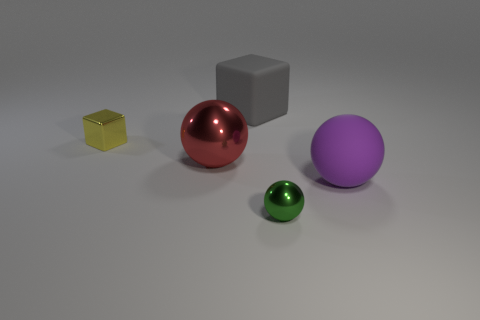Add 3 tiny gray matte spheres. How many objects exist? 8 Subtract all balls. How many objects are left? 2 Add 2 large rubber objects. How many large rubber objects are left? 4 Add 5 big cyan spheres. How many big cyan spheres exist? 5 Subtract 1 red balls. How many objects are left? 4 Subtract all red spheres. Subtract all tiny green shiny things. How many objects are left? 3 